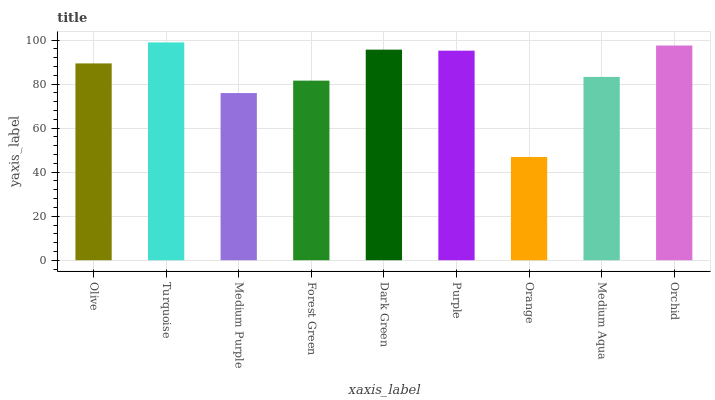Is Orange the minimum?
Answer yes or no. Yes. Is Turquoise the maximum?
Answer yes or no. Yes. Is Medium Purple the minimum?
Answer yes or no. No. Is Medium Purple the maximum?
Answer yes or no. No. Is Turquoise greater than Medium Purple?
Answer yes or no. Yes. Is Medium Purple less than Turquoise?
Answer yes or no. Yes. Is Medium Purple greater than Turquoise?
Answer yes or no. No. Is Turquoise less than Medium Purple?
Answer yes or no. No. Is Olive the high median?
Answer yes or no. Yes. Is Olive the low median?
Answer yes or no. Yes. Is Medium Purple the high median?
Answer yes or no. No. Is Medium Aqua the low median?
Answer yes or no. No. 